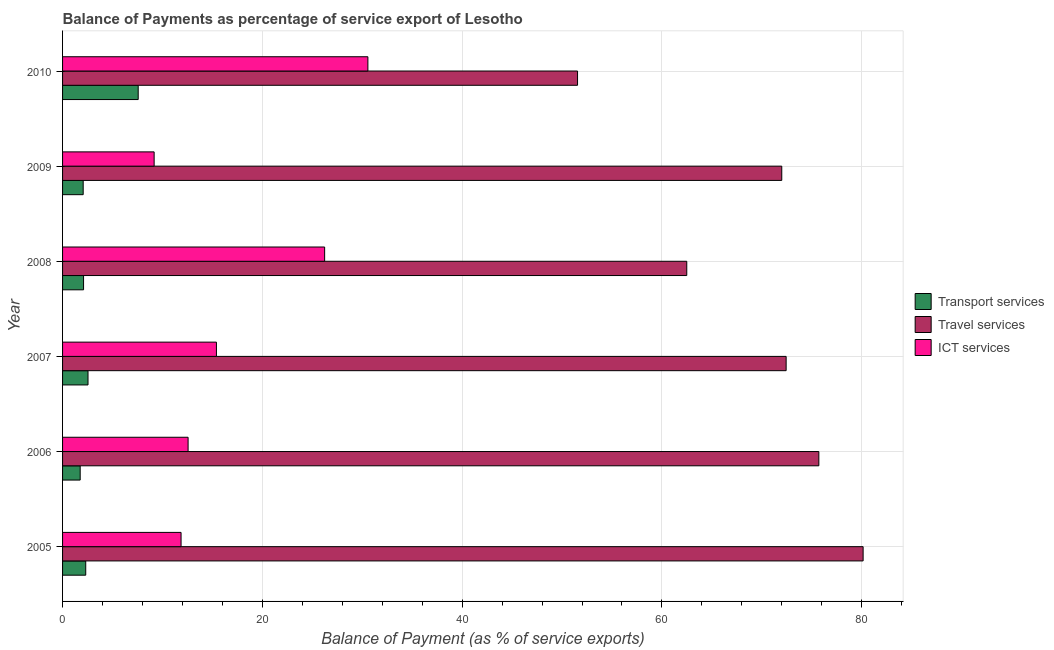Are the number of bars per tick equal to the number of legend labels?
Ensure brevity in your answer.  Yes. How many bars are there on the 1st tick from the top?
Give a very brief answer. 3. In how many cases, is the number of bars for a given year not equal to the number of legend labels?
Your answer should be compact. 0. What is the balance of payment of transport services in 2006?
Ensure brevity in your answer.  1.76. Across all years, what is the maximum balance of payment of ict services?
Provide a succinct answer. 30.56. Across all years, what is the minimum balance of payment of transport services?
Make the answer very short. 1.76. What is the total balance of payment of travel services in the graph?
Offer a terse response. 414.3. What is the difference between the balance of payment of transport services in 2007 and that in 2010?
Your answer should be very brief. -5.02. What is the difference between the balance of payment of travel services in 2010 and the balance of payment of ict services in 2008?
Offer a terse response. 25.32. What is the average balance of payment of travel services per year?
Provide a short and direct response. 69.05. In the year 2008, what is the difference between the balance of payment of travel services and balance of payment of ict services?
Offer a terse response. 36.25. What is the ratio of the balance of payment of ict services in 2009 to that in 2010?
Make the answer very short. 0.3. What is the difference between the highest and the second highest balance of payment of travel services?
Ensure brevity in your answer.  4.43. What is the difference between the highest and the lowest balance of payment of travel services?
Your answer should be compact. 28.59. In how many years, is the balance of payment of travel services greater than the average balance of payment of travel services taken over all years?
Your answer should be compact. 4. What does the 1st bar from the top in 2005 represents?
Make the answer very short. ICT services. What does the 3rd bar from the bottom in 2005 represents?
Your response must be concise. ICT services. Is it the case that in every year, the sum of the balance of payment of transport services and balance of payment of travel services is greater than the balance of payment of ict services?
Keep it short and to the point. Yes. How many bars are there?
Keep it short and to the point. 18. Does the graph contain any zero values?
Keep it short and to the point. No. Where does the legend appear in the graph?
Provide a succinct answer. Center right. How many legend labels are there?
Give a very brief answer. 3. How are the legend labels stacked?
Ensure brevity in your answer.  Vertical. What is the title of the graph?
Keep it short and to the point. Balance of Payments as percentage of service export of Lesotho. What is the label or title of the X-axis?
Your answer should be very brief. Balance of Payment (as % of service exports). What is the Balance of Payment (as % of service exports) in Transport services in 2005?
Your answer should be very brief. 2.32. What is the Balance of Payment (as % of service exports) of Travel services in 2005?
Your answer should be very brief. 80.14. What is the Balance of Payment (as % of service exports) in ICT services in 2005?
Provide a short and direct response. 11.86. What is the Balance of Payment (as % of service exports) of Transport services in 2006?
Offer a terse response. 1.76. What is the Balance of Payment (as % of service exports) of Travel services in 2006?
Ensure brevity in your answer.  75.71. What is the Balance of Payment (as % of service exports) of ICT services in 2006?
Give a very brief answer. 12.57. What is the Balance of Payment (as % of service exports) in Transport services in 2007?
Your response must be concise. 2.55. What is the Balance of Payment (as % of service exports) of Travel services in 2007?
Keep it short and to the point. 72.43. What is the Balance of Payment (as % of service exports) in ICT services in 2007?
Your answer should be very brief. 15.4. What is the Balance of Payment (as % of service exports) in Transport services in 2008?
Ensure brevity in your answer.  2.1. What is the Balance of Payment (as % of service exports) in Travel services in 2008?
Your answer should be compact. 62.48. What is the Balance of Payment (as % of service exports) of ICT services in 2008?
Offer a terse response. 26.24. What is the Balance of Payment (as % of service exports) in Transport services in 2009?
Provide a short and direct response. 2.06. What is the Balance of Payment (as % of service exports) of Travel services in 2009?
Offer a very short reply. 71.99. What is the Balance of Payment (as % of service exports) of ICT services in 2009?
Your answer should be compact. 9.17. What is the Balance of Payment (as % of service exports) in Transport services in 2010?
Your answer should be very brief. 7.57. What is the Balance of Payment (as % of service exports) in Travel services in 2010?
Make the answer very short. 51.55. What is the Balance of Payment (as % of service exports) of ICT services in 2010?
Your answer should be compact. 30.56. Across all years, what is the maximum Balance of Payment (as % of service exports) of Transport services?
Ensure brevity in your answer.  7.57. Across all years, what is the maximum Balance of Payment (as % of service exports) in Travel services?
Offer a terse response. 80.14. Across all years, what is the maximum Balance of Payment (as % of service exports) of ICT services?
Offer a very short reply. 30.56. Across all years, what is the minimum Balance of Payment (as % of service exports) of Transport services?
Offer a terse response. 1.76. Across all years, what is the minimum Balance of Payment (as % of service exports) of Travel services?
Make the answer very short. 51.55. Across all years, what is the minimum Balance of Payment (as % of service exports) in ICT services?
Offer a very short reply. 9.17. What is the total Balance of Payment (as % of service exports) of Transport services in the graph?
Make the answer very short. 18.37. What is the total Balance of Payment (as % of service exports) in Travel services in the graph?
Your answer should be very brief. 414.3. What is the total Balance of Payment (as % of service exports) of ICT services in the graph?
Your answer should be compact. 105.8. What is the difference between the Balance of Payment (as % of service exports) in Transport services in 2005 and that in 2006?
Your answer should be compact. 0.56. What is the difference between the Balance of Payment (as % of service exports) of Travel services in 2005 and that in 2006?
Ensure brevity in your answer.  4.43. What is the difference between the Balance of Payment (as % of service exports) of ICT services in 2005 and that in 2006?
Your answer should be compact. -0.7. What is the difference between the Balance of Payment (as % of service exports) in Transport services in 2005 and that in 2007?
Give a very brief answer. -0.23. What is the difference between the Balance of Payment (as % of service exports) in Travel services in 2005 and that in 2007?
Your response must be concise. 7.71. What is the difference between the Balance of Payment (as % of service exports) in ICT services in 2005 and that in 2007?
Keep it short and to the point. -3.54. What is the difference between the Balance of Payment (as % of service exports) of Transport services in 2005 and that in 2008?
Make the answer very short. 0.22. What is the difference between the Balance of Payment (as % of service exports) of Travel services in 2005 and that in 2008?
Provide a succinct answer. 17.65. What is the difference between the Balance of Payment (as % of service exports) of ICT services in 2005 and that in 2008?
Provide a succinct answer. -14.37. What is the difference between the Balance of Payment (as % of service exports) in Transport services in 2005 and that in 2009?
Provide a short and direct response. 0.26. What is the difference between the Balance of Payment (as % of service exports) in Travel services in 2005 and that in 2009?
Your answer should be compact. 8.14. What is the difference between the Balance of Payment (as % of service exports) in ICT services in 2005 and that in 2009?
Keep it short and to the point. 2.7. What is the difference between the Balance of Payment (as % of service exports) of Transport services in 2005 and that in 2010?
Ensure brevity in your answer.  -5.25. What is the difference between the Balance of Payment (as % of service exports) of Travel services in 2005 and that in 2010?
Your answer should be very brief. 28.59. What is the difference between the Balance of Payment (as % of service exports) of ICT services in 2005 and that in 2010?
Keep it short and to the point. -18.7. What is the difference between the Balance of Payment (as % of service exports) of Transport services in 2006 and that in 2007?
Give a very brief answer. -0.78. What is the difference between the Balance of Payment (as % of service exports) of Travel services in 2006 and that in 2007?
Your answer should be compact. 3.27. What is the difference between the Balance of Payment (as % of service exports) in ICT services in 2006 and that in 2007?
Ensure brevity in your answer.  -2.84. What is the difference between the Balance of Payment (as % of service exports) in Transport services in 2006 and that in 2008?
Give a very brief answer. -0.34. What is the difference between the Balance of Payment (as % of service exports) in Travel services in 2006 and that in 2008?
Offer a very short reply. 13.22. What is the difference between the Balance of Payment (as % of service exports) in ICT services in 2006 and that in 2008?
Ensure brevity in your answer.  -13.67. What is the difference between the Balance of Payment (as % of service exports) in Transport services in 2006 and that in 2009?
Your answer should be compact. -0.3. What is the difference between the Balance of Payment (as % of service exports) in Travel services in 2006 and that in 2009?
Ensure brevity in your answer.  3.71. What is the difference between the Balance of Payment (as % of service exports) of ICT services in 2006 and that in 2009?
Your response must be concise. 3.4. What is the difference between the Balance of Payment (as % of service exports) of Transport services in 2006 and that in 2010?
Give a very brief answer. -5.81. What is the difference between the Balance of Payment (as % of service exports) of Travel services in 2006 and that in 2010?
Provide a succinct answer. 24.15. What is the difference between the Balance of Payment (as % of service exports) in ICT services in 2006 and that in 2010?
Your answer should be very brief. -18. What is the difference between the Balance of Payment (as % of service exports) in Transport services in 2007 and that in 2008?
Your response must be concise. 0.45. What is the difference between the Balance of Payment (as % of service exports) of Travel services in 2007 and that in 2008?
Provide a short and direct response. 9.95. What is the difference between the Balance of Payment (as % of service exports) in ICT services in 2007 and that in 2008?
Your response must be concise. -10.83. What is the difference between the Balance of Payment (as % of service exports) in Transport services in 2007 and that in 2009?
Offer a terse response. 0.48. What is the difference between the Balance of Payment (as % of service exports) in Travel services in 2007 and that in 2009?
Keep it short and to the point. 0.44. What is the difference between the Balance of Payment (as % of service exports) of ICT services in 2007 and that in 2009?
Make the answer very short. 6.24. What is the difference between the Balance of Payment (as % of service exports) of Transport services in 2007 and that in 2010?
Your response must be concise. -5.02. What is the difference between the Balance of Payment (as % of service exports) in Travel services in 2007 and that in 2010?
Your response must be concise. 20.88. What is the difference between the Balance of Payment (as % of service exports) of ICT services in 2007 and that in 2010?
Make the answer very short. -15.16. What is the difference between the Balance of Payment (as % of service exports) in Transport services in 2008 and that in 2009?
Offer a very short reply. 0.04. What is the difference between the Balance of Payment (as % of service exports) in Travel services in 2008 and that in 2009?
Your response must be concise. -9.51. What is the difference between the Balance of Payment (as % of service exports) in ICT services in 2008 and that in 2009?
Your response must be concise. 17.07. What is the difference between the Balance of Payment (as % of service exports) in Transport services in 2008 and that in 2010?
Make the answer very short. -5.47. What is the difference between the Balance of Payment (as % of service exports) in Travel services in 2008 and that in 2010?
Make the answer very short. 10.93. What is the difference between the Balance of Payment (as % of service exports) of ICT services in 2008 and that in 2010?
Provide a succinct answer. -4.33. What is the difference between the Balance of Payment (as % of service exports) in Transport services in 2009 and that in 2010?
Your response must be concise. -5.51. What is the difference between the Balance of Payment (as % of service exports) in Travel services in 2009 and that in 2010?
Ensure brevity in your answer.  20.44. What is the difference between the Balance of Payment (as % of service exports) in ICT services in 2009 and that in 2010?
Your answer should be compact. -21.4. What is the difference between the Balance of Payment (as % of service exports) in Transport services in 2005 and the Balance of Payment (as % of service exports) in Travel services in 2006?
Your answer should be very brief. -73.39. What is the difference between the Balance of Payment (as % of service exports) of Transport services in 2005 and the Balance of Payment (as % of service exports) of ICT services in 2006?
Ensure brevity in your answer.  -10.25. What is the difference between the Balance of Payment (as % of service exports) of Travel services in 2005 and the Balance of Payment (as % of service exports) of ICT services in 2006?
Make the answer very short. 67.57. What is the difference between the Balance of Payment (as % of service exports) in Transport services in 2005 and the Balance of Payment (as % of service exports) in Travel services in 2007?
Provide a short and direct response. -70.11. What is the difference between the Balance of Payment (as % of service exports) of Transport services in 2005 and the Balance of Payment (as % of service exports) of ICT services in 2007?
Offer a very short reply. -13.08. What is the difference between the Balance of Payment (as % of service exports) in Travel services in 2005 and the Balance of Payment (as % of service exports) in ICT services in 2007?
Ensure brevity in your answer.  64.73. What is the difference between the Balance of Payment (as % of service exports) in Transport services in 2005 and the Balance of Payment (as % of service exports) in Travel services in 2008?
Offer a very short reply. -60.16. What is the difference between the Balance of Payment (as % of service exports) in Transport services in 2005 and the Balance of Payment (as % of service exports) in ICT services in 2008?
Make the answer very short. -23.92. What is the difference between the Balance of Payment (as % of service exports) in Travel services in 2005 and the Balance of Payment (as % of service exports) in ICT services in 2008?
Make the answer very short. 53.9. What is the difference between the Balance of Payment (as % of service exports) in Transport services in 2005 and the Balance of Payment (as % of service exports) in Travel services in 2009?
Your answer should be very brief. -69.67. What is the difference between the Balance of Payment (as % of service exports) in Transport services in 2005 and the Balance of Payment (as % of service exports) in ICT services in 2009?
Offer a terse response. -6.85. What is the difference between the Balance of Payment (as % of service exports) of Travel services in 2005 and the Balance of Payment (as % of service exports) of ICT services in 2009?
Your answer should be very brief. 70.97. What is the difference between the Balance of Payment (as % of service exports) of Transport services in 2005 and the Balance of Payment (as % of service exports) of Travel services in 2010?
Give a very brief answer. -49.23. What is the difference between the Balance of Payment (as % of service exports) of Transport services in 2005 and the Balance of Payment (as % of service exports) of ICT services in 2010?
Provide a short and direct response. -28.24. What is the difference between the Balance of Payment (as % of service exports) in Travel services in 2005 and the Balance of Payment (as % of service exports) in ICT services in 2010?
Your response must be concise. 49.57. What is the difference between the Balance of Payment (as % of service exports) in Transport services in 2006 and the Balance of Payment (as % of service exports) in Travel services in 2007?
Make the answer very short. -70.67. What is the difference between the Balance of Payment (as % of service exports) of Transport services in 2006 and the Balance of Payment (as % of service exports) of ICT services in 2007?
Make the answer very short. -13.64. What is the difference between the Balance of Payment (as % of service exports) of Travel services in 2006 and the Balance of Payment (as % of service exports) of ICT services in 2007?
Provide a short and direct response. 60.3. What is the difference between the Balance of Payment (as % of service exports) of Transport services in 2006 and the Balance of Payment (as % of service exports) of Travel services in 2008?
Offer a very short reply. -60.72. What is the difference between the Balance of Payment (as % of service exports) of Transport services in 2006 and the Balance of Payment (as % of service exports) of ICT services in 2008?
Your answer should be compact. -24.47. What is the difference between the Balance of Payment (as % of service exports) of Travel services in 2006 and the Balance of Payment (as % of service exports) of ICT services in 2008?
Your answer should be compact. 49.47. What is the difference between the Balance of Payment (as % of service exports) of Transport services in 2006 and the Balance of Payment (as % of service exports) of Travel services in 2009?
Ensure brevity in your answer.  -70.23. What is the difference between the Balance of Payment (as % of service exports) in Transport services in 2006 and the Balance of Payment (as % of service exports) in ICT services in 2009?
Your response must be concise. -7.4. What is the difference between the Balance of Payment (as % of service exports) in Travel services in 2006 and the Balance of Payment (as % of service exports) in ICT services in 2009?
Keep it short and to the point. 66.54. What is the difference between the Balance of Payment (as % of service exports) in Transport services in 2006 and the Balance of Payment (as % of service exports) in Travel services in 2010?
Offer a terse response. -49.79. What is the difference between the Balance of Payment (as % of service exports) of Transport services in 2006 and the Balance of Payment (as % of service exports) of ICT services in 2010?
Your answer should be very brief. -28.8. What is the difference between the Balance of Payment (as % of service exports) in Travel services in 2006 and the Balance of Payment (as % of service exports) in ICT services in 2010?
Ensure brevity in your answer.  45.14. What is the difference between the Balance of Payment (as % of service exports) of Transport services in 2007 and the Balance of Payment (as % of service exports) of Travel services in 2008?
Your response must be concise. -59.94. What is the difference between the Balance of Payment (as % of service exports) of Transport services in 2007 and the Balance of Payment (as % of service exports) of ICT services in 2008?
Provide a succinct answer. -23.69. What is the difference between the Balance of Payment (as % of service exports) in Travel services in 2007 and the Balance of Payment (as % of service exports) in ICT services in 2008?
Offer a very short reply. 46.2. What is the difference between the Balance of Payment (as % of service exports) in Transport services in 2007 and the Balance of Payment (as % of service exports) in Travel services in 2009?
Provide a short and direct response. -69.45. What is the difference between the Balance of Payment (as % of service exports) of Transport services in 2007 and the Balance of Payment (as % of service exports) of ICT services in 2009?
Provide a short and direct response. -6.62. What is the difference between the Balance of Payment (as % of service exports) in Travel services in 2007 and the Balance of Payment (as % of service exports) in ICT services in 2009?
Your response must be concise. 63.27. What is the difference between the Balance of Payment (as % of service exports) of Transport services in 2007 and the Balance of Payment (as % of service exports) of Travel services in 2010?
Make the answer very short. -49. What is the difference between the Balance of Payment (as % of service exports) in Transport services in 2007 and the Balance of Payment (as % of service exports) in ICT services in 2010?
Your response must be concise. -28.02. What is the difference between the Balance of Payment (as % of service exports) in Travel services in 2007 and the Balance of Payment (as % of service exports) in ICT services in 2010?
Your answer should be very brief. 41.87. What is the difference between the Balance of Payment (as % of service exports) in Transport services in 2008 and the Balance of Payment (as % of service exports) in Travel services in 2009?
Keep it short and to the point. -69.89. What is the difference between the Balance of Payment (as % of service exports) in Transport services in 2008 and the Balance of Payment (as % of service exports) in ICT services in 2009?
Offer a terse response. -7.06. What is the difference between the Balance of Payment (as % of service exports) in Travel services in 2008 and the Balance of Payment (as % of service exports) in ICT services in 2009?
Keep it short and to the point. 53.32. What is the difference between the Balance of Payment (as % of service exports) of Transport services in 2008 and the Balance of Payment (as % of service exports) of Travel services in 2010?
Make the answer very short. -49.45. What is the difference between the Balance of Payment (as % of service exports) of Transport services in 2008 and the Balance of Payment (as % of service exports) of ICT services in 2010?
Keep it short and to the point. -28.46. What is the difference between the Balance of Payment (as % of service exports) of Travel services in 2008 and the Balance of Payment (as % of service exports) of ICT services in 2010?
Your answer should be very brief. 31.92. What is the difference between the Balance of Payment (as % of service exports) of Transport services in 2009 and the Balance of Payment (as % of service exports) of Travel services in 2010?
Your answer should be compact. -49.49. What is the difference between the Balance of Payment (as % of service exports) in Transport services in 2009 and the Balance of Payment (as % of service exports) in ICT services in 2010?
Give a very brief answer. -28.5. What is the difference between the Balance of Payment (as % of service exports) in Travel services in 2009 and the Balance of Payment (as % of service exports) in ICT services in 2010?
Your answer should be very brief. 41.43. What is the average Balance of Payment (as % of service exports) in Transport services per year?
Offer a very short reply. 3.06. What is the average Balance of Payment (as % of service exports) in Travel services per year?
Make the answer very short. 69.05. What is the average Balance of Payment (as % of service exports) in ICT services per year?
Keep it short and to the point. 17.63. In the year 2005, what is the difference between the Balance of Payment (as % of service exports) in Transport services and Balance of Payment (as % of service exports) in Travel services?
Provide a short and direct response. -77.82. In the year 2005, what is the difference between the Balance of Payment (as % of service exports) of Transport services and Balance of Payment (as % of service exports) of ICT services?
Provide a short and direct response. -9.54. In the year 2005, what is the difference between the Balance of Payment (as % of service exports) of Travel services and Balance of Payment (as % of service exports) of ICT services?
Offer a very short reply. 68.28. In the year 2006, what is the difference between the Balance of Payment (as % of service exports) of Transport services and Balance of Payment (as % of service exports) of Travel services?
Provide a succinct answer. -73.94. In the year 2006, what is the difference between the Balance of Payment (as % of service exports) of Transport services and Balance of Payment (as % of service exports) of ICT services?
Your answer should be very brief. -10.8. In the year 2006, what is the difference between the Balance of Payment (as % of service exports) in Travel services and Balance of Payment (as % of service exports) in ICT services?
Provide a succinct answer. 63.14. In the year 2007, what is the difference between the Balance of Payment (as % of service exports) in Transport services and Balance of Payment (as % of service exports) in Travel services?
Provide a succinct answer. -69.88. In the year 2007, what is the difference between the Balance of Payment (as % of service exports) in Transport services and Balance of Payment (as % of service exports) in ICT services?
Your answer should be very brief. -12.86. In the year 2007, what is the difference between the Balance of Payment (as % of service exports) of Travel services and Balance of Payment (as % of service exports) of ICT services?
Offer a very short reply. 57.03. In the year 2008, what is the difference between the Balance of Payment (as % of service exports) of Transport services and Balance of Payment (as % of service exports) of Travel services?
Offer a very short reply. -60.38. In the year 2008, what is the difference between the Balance of Payment (as % of service exports) of Transport services and Balance of Payment (as % of service exports) of ICT services?
Make the answer very short. -24.13. In the year 2008, what is the difference between the Balance of Payment (as % of service exports) in Travel services and Balance of Payment (as % of service exports) in ICT services?
Your response must be concise. 36.25. In the year 2009, what is the difference between the Balance of Payment (as % of service exports) in Transport services and Balance of Payment (as % of service exports) in Travel services?
Offer a terse response. -69.93. In the year 2009, what is the difference between the Balance of Payment (as % of service exports) in Transport services and Balance of Payment (as % of service exports) in ICT services?
Give a very brief answer. -7.1. In the year 2009, what is the difference between the Balance of Payment (as % of service exports) in Travel services and Balance of Payment (as % of service exports) in ICT services?
Keep it short and to the point. 62.83. In the year 2010, what is the difference between the Balance of Payment (as % of service exports) in Transport services and Balance of Payment (as % of service exports) in Travel services?
Give a very brief answer. -43.98. In the year 2010, what is the difference between the Balance of Payment (as % of service exports) in Transport services and Balance of Payment (as % of service exports) in ICT services?
Offer a very short reply. -22.99. In the year 2010, what is the difference between the Balance of Payment (as % of service exports) in Travel services and Balance of Payment (as % of service exports) in ICT services?
Your response must be concise. 20.99. What is the ratio of the Balance of Payment (as % of service exports) in Transport services in 2005 to that in 2006?
Offer a terse response. 1.31. What is the ratio of the Balance of Payment (as % of service exports) in Travel services in 2005 to that in 2006?
Offer a very short reply. 1.06. What is the ratio of the Balance of Payment (as % of service exports) in ICT services in 2005 to that in 2006?
Your response must be concise. 0.94. What is the ratio of the Balance of Payment (as % of service exports) of Transport services in 2005 to that in 2007?
Ensure brevity in your answer.  0.91. What is the ratio of the Balance of Payment (as % of service exports) of Travel services in 2005 to that in 2007?
Offer a very short reply. 1.11. What is the ratio of the Balance of Payment (as % of service exports) of ICT services in 2005 to that in 2007?
Your response must be concise. 0.77. What is the ratio of the Balance of Payment (as % of service exports) in Transport services in 2005 to that in 2008?
Ensure brevity in your answer.  1.1. What is the ratio of the Balance of Payment (as % of service exports) of Travel services in 2005 to that in 2008?
Your response must be concise. 1.28. What is the ratio of the Balance of Payment (as % of service exports) of ICT services in 2005 to that in 2008?
Make the answer very short. 0.45. What is the ratio of the Balance of Payment (as % of service exports) of Transport services in 2005 to that in 2009?
Keep it short and to the point. 1.12. What is the ratio of the Balance of Payment (as % of service exports) of Travel services in 2005 to that in 2009?
Your answer should be very brief. 1.11. What is the ratio of the Balance of Payment (as % of service exports) of ICT services in 2005 to that in 2009?
Keep it short and to the point. 1.29. What is the ratio of the Balance of Payment (as % of service exports) of Transport services in 2005 to that in 2010?
Offer a very short reply. 0.31. What is the ratio of the Balance of Payment (as % of service exports) in Travel services in 2005 to that in 2010?
Your answer should be compact. 1.55. What is the ratio of the Balance of Payment (as % of service exports) in ICT services in 2005 to that in 2010?
Provide a succinct answer. 0.39. What is the ratio of the Balance of Payment (as % of service exports) of Transport services in 2006 to that in 2007?
Your response must be concise. 0.69. What is the ratio of the Balance of Payment (as % of service exports) in Travel services in 2006 to that in 2007?
Keep it short and to the point. 1.05. What is the ratio of the Balance of Payment (as % of service exports) of ICT services in 2006 to that in 2007?
Provide a short and direct response. 0.82. What is the ratio of the Balance of Payment (as % of service exports) in Transport services in 2006 to that in 2008?
Keep it short and to the point. 0.84. What is the ratio of the Balance of Payment (as % of service exports) in Travel services in 2006 to that in 2008?
Ensure brevity in your answer.  1.21. What is the ratio of the Balance of Payment (as % of service exports) in ICT services in 2006 to that in 2008?
Offer a terse response. 0.48. What is the ratio of the Balance of Payment (as % of service exports) of Transport services in 2006 to that in 2009?
Provide a succinct answer. 0.85. What is the ratio of the Balance of Payment (as % of service exports) in Travel services in 2006 to that in 2009?
Keep it short and to the point. 1.05. What is the ratio of the Balance of Payment (as % of service exports) of ICT services in 2006 to that in 2009?
Offer a terse response. 1.37. What is the ratio of the Balance of Payment (as % of service exports) of Transport services in 2006 to that in 2010?
Offer a very short reply. 0.23. What is the ratio of the Balance of Payment (as % of service exports) of Travel services in 2006 to that in 2010?
Your answer should be compact. 1.47. What is the ratio of the Balance of Payment (as % of service exports) in ICT services in 2006 to that in 2010?
Give a very brief answer. 0.41. What is the ratio of the Balance of Payment (as % of service exports) of Transport services in 2007 to that in 2008?
Offer a terse response. 1.21. What is the ratio of the Balance of Payment (as % of service exports) in Travel services in 2007 to that in 2008?
Your answer should be very brief. 1.16. What is the ratio of the Balance of Payment (as % of service exports) in ICT services in 2007 to that in 2008?
Your answer should be compact. 0.59. What is the ratio of the Balance of Payment (as % of service exports) in Transport services in 2007 to that in 2009?
Your answer should be very brief. 1.23. What is the ratio of the Balance of Payment (as % of service exports) of ICT services in 2007 to that in 2009?
Your answer should be very brief. 1.68. What is the ratio of the Balance of Payment (as % of service exports) of Transport services in 2007 to that in 2010?
Your answer should be compact. 0.34. What is the ratio of the Balance of Payment (as % of service exports) in Travel services in 2007 to that in 2010?
Give a very brief answer. 1.41. What is the ratio of the Balance of Payment (as % of service exports) of ICT services in 2007 to that in 2010?
Make the answer very short. 0.5. What is the ratio of the Balance of Payment (as % of service exports) in Transport services in 2008 to that in 2009?
Your answer should be compact. 1.02. What is the ratio of the Balance of Payment (as % of service exports) of Travel services in 2008 to that in 2009?
Make the answer very short. 0.87. What is the ratio of the Balance of Payment (as % of service exports) in ICT services in 2008 to that in 2009?
Your response must be concise. 2.86. What is the ratio of the Balance of Payment (as % of service exports) of Transport services in 2008 to that in 2010?
Give a very brief answer. 0.28. What is the ratio of the Balance of Payment (as % of service exports) of Travel services in 2008 to that in 2010?
Offer a very short reply. 1.21. What is the ratio of the Balance of Payment (as % of service exports) in ICT services in 2008 to that in 2010?
Your response must be concise. 0.86. What is the ratio of the Balance of Payment (as % of service exports) of Transport services in 2009 to that in 2010?
Make the answer very short. 0.27. What is the ratio of the Balance of Payment (as % of service exports) of Travel services in 2009 to that in 2010?
Your response must be concise. 1.4. What is the ratio of the Balance of Payment (as % of service exports) of ICT services in 2009 to that in 2010?
Make the answer very short. 0.3. What is the difference between the highest and the second highest Balance of Payment (as % of service exports) in Transport services?
Offer a very short reply. 5.02. What is the difference between the highest and the second highest Balance of Payment (as % of service exports) of Travel services?
Your response must be concise. 4.43. What is the difference between the highest and the second highest Balance of Payment (as % of service exports) in ICT services?
Provide a succinct answer. 4.33. What is the difference between the highest and the lowest Balance of Payment (as % of service exports) of Transport services?
Your answer should be compact. 5.81. What is the difference between the highest and the lowest Balance of Payment (as % of service exports) of Travel services?
Offer a very short reply. 28.59. What is the difference between the highest and the lowest Balance of Payment (as % of service exports) of ICT services?
Make the answer very short. 21.4. 